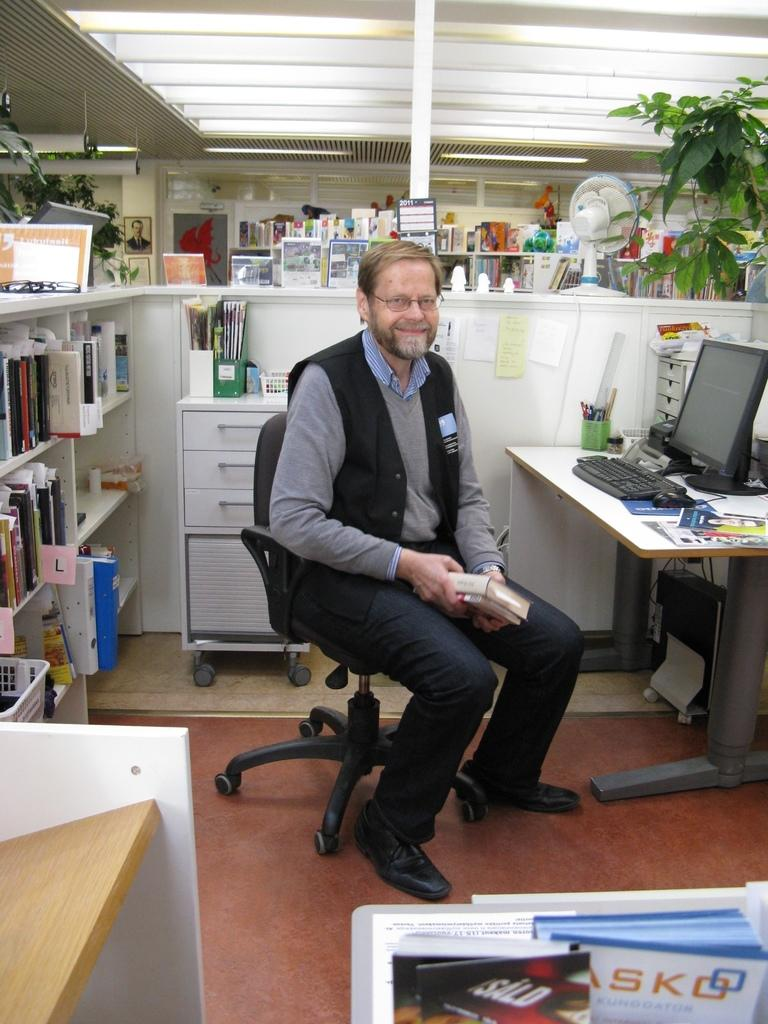<image>
Offer a succinct explanation of the picture presented. A filing shelf indicates the L section behind a man at a desk. 